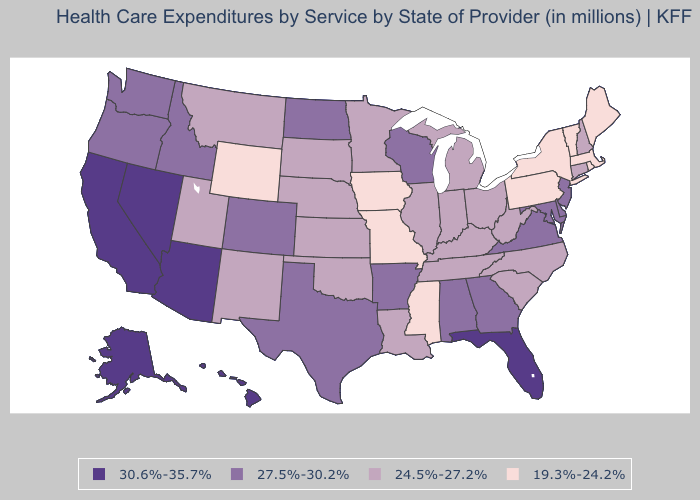Among the states that border Texas , does Oklahoma have the highest value?
Give a very brief answer. No. Which states have the highest value in the USA?
Give a very brief answer. Alaska, Arizona, California, Florida, Hawaii, Nevada. Which states hav the highest value in the MidWest?
Quick response, please. North Dakota, Wisconsin. What is the value of Alabama?
Give a very brief answer. 27.5%-30.2%. Name the states that have a value in the range 24.5%-27.2%?
Concise answer only. Connecticut, Illinois, Indiana, Kansas, Kentucky, Louisiana, Michigan, Minnesota, Montana, Nebraska, New Hampshire, New Mexico, North Carolina, Ohio, Oklahoma, South Carolina, South Dakota, Tennessee, Utah, West Virginia. What is the value of Maryland?
Quick response, please. 27.5%-30.2%. Does North Dakota have a lower value than South Carolina?
Write a very short answer. No. Among the states that border New Mexico , does Texas have the highest value?
Give a very brief answer. No. What is the lowest value in states that border Florida?
Quick response, please. 27.5%-30.2%. What is the value of Alaska?
Quick response, please. 30.6%-35.7%. What is the lowest value in states that border Indiana?
Answer briefly. 24.5%-27.2%. What is the lowest value in the MidWest?
Concise answer only. 19.3%-24.2%. Name the states that have a value in the range 30.6%-35.7%?
Concise answer only. Alaska, Arizona, California, Florida, Hawaii, Nevada. What is the value of Massachusetts?
Be succinct. 19.3%-24.2%. 